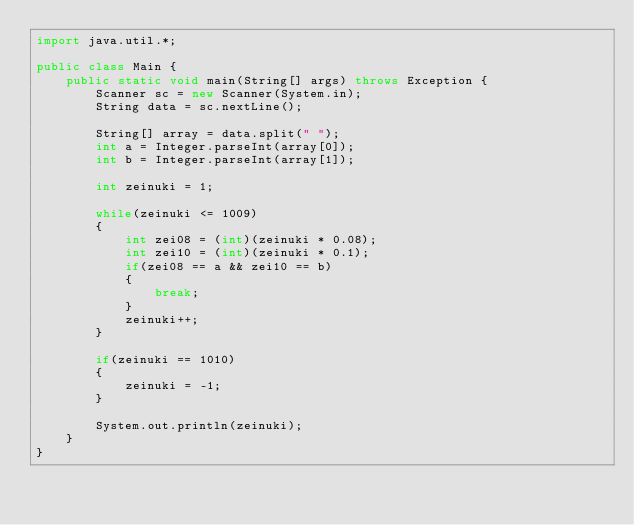Convert code to text. <code><loc_0><loc_0><loc_500><loc_500><_Java_>import java.util.*;

public class Main {
    public static void main(String[] args) throws Exception {
        Scanner sc = new Scanner(System.in);
        String data = sc.nextLine();
        
        String[] array = data.split(" ");
        int a = Integer.parseInt(array[0]);
        int b = Integer.parseInt(array[1]);
        
        int zeinuki = 1;
        
        while(zeinuki <= 1009)
        {
            int zei08 = (int)(zeinuki * 0.08);
            int zei10 = (int)(zeinuki * 0.1);
            if(zei08 == a && zei10 == b)
            {
                break;
            }
            zeinuki++;
        }
        
        if(zeinuki == 1010)
        {
            zeinuki = -1;
        }
        
        System.out.println(zeinuki);
    }
}
</code> 